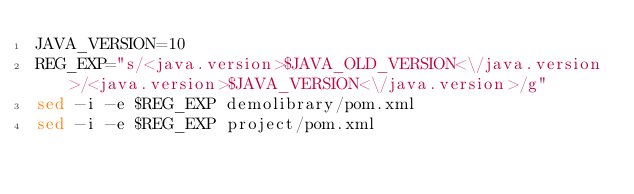<code> <loc_0><loc_0><loc_500><loc_500><_Bash_>JAVA_VERSION=10
REG_EXP="s/<java.version>$JAVA_OLD_VERSION<\/java.version>/<java.version>$JAVA_VERSION<\/java.version>/g" 
sed -i -e $REG_EXP demolibrary/pom.xml 
sed -i -e $REG_EXP project/pom.xml </code> 